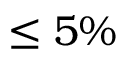<formula> <loc_0><loc_0><loc_500><loc_500>\leq 5 \%</formula> 